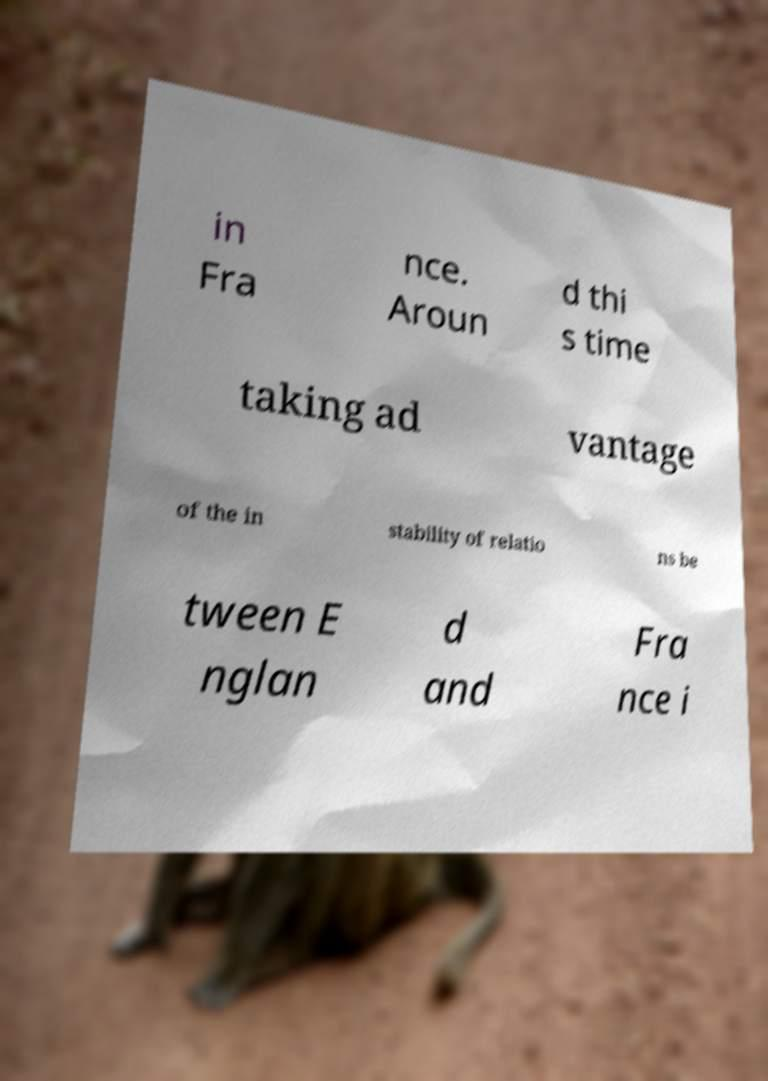Can you accurately transcribe the text from the provided image for me? in Fra nce. Aroun d thi s time taking ad vantage of the in stability of relatio ns be tween E nglan d and Fra nce i 